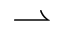Convert formula to latex. <formula><loc_0><loc_0><loc_500><loc_500>\rightharpoonup</formula> 